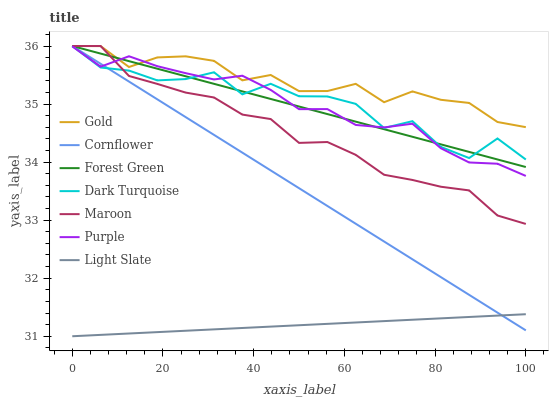Does Light Slate have the minimum area under the curve?
Answer yes or no. Yes. Does Gold have the maximum area under the curve?
Answer yes or no. Yes. Does Purple have the minimum area under the curve?
Answer yes or no. No. Does Purple have the maximum area under the curve?
Answer yes or no. No. Is Light Slate the smoothest?
Answer yes or no. Yes. Is Dark Turquoise the roughest?
Answer yes or no. Yes. Is Gold the smoothest?
Answer yes or no. No. Is Gold the roughest?
Answer yes or no. No. Does Light Slate have the lowest value?
Answer yes or no. Yes. Does Purple have the lowest value?
Answer yes or no. No. Does Forest Green have the highest value?
Answer yes or no. Yes. Does Purple have the highest value?
Answer yes or no. No. Is Light Slate less than Maroon?
Answer yes or no. Yes. Is Forest Green greater than Light Slate?
Answer yes or no. Yes. Does Forest Green intersect Maroon?
Answer yes or no. Yes. Is Forest Green less than Maroon?
Answer yes or no. No. Is Forest Green greater than Maroon?
Answer yes or no. No. Does Light Slate intersect Maroon?
Answer yes or no. No. 